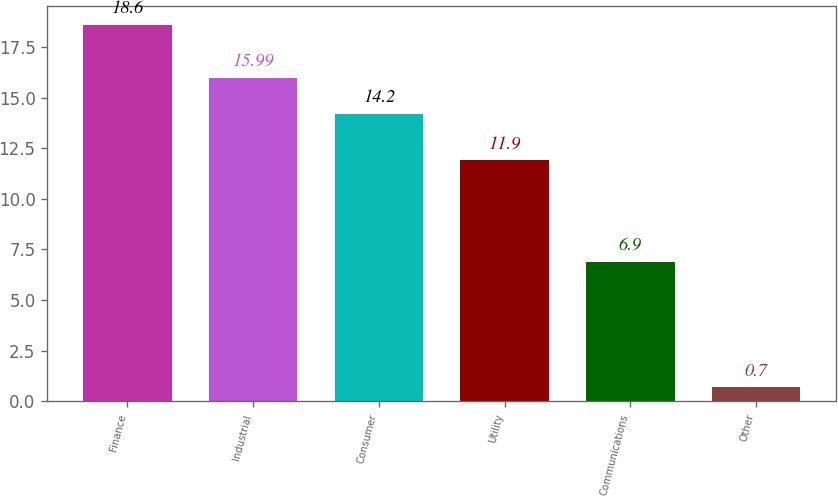Convert chart. <chart><loc_0><loc_0><loc_500><loc_500><bar_chart><fcel>Finance<fcel>Industrial<fcel>Consumer<fcel>Utility<fcel>Communications<fcel>Other<nl><fcel>18.6<fcel>15.99<fcel>14.2<fcel>11.9<fcel>6.9<fcel>0.7<nl></chart> 